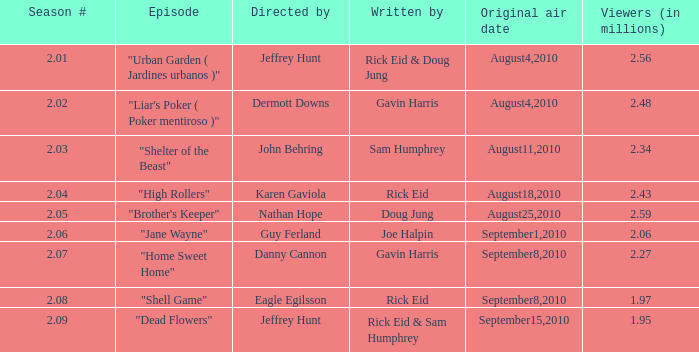If the amount of viewers is 2.48 million, what is the original air date? August4,2010. 